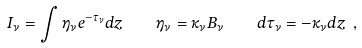Convert formula to latex. <formula><loc_0><loc_0><loc_500><loc_500>I _ { \nu } = \int \eta _ { \nu } e ^ { - \tau _ { \nu } } d z \quad \eta _ { \nu } = \kappa _ { \nu } B _ { \nu } \quad d \tau _ { \nu } = - \kappa _ { \nu } d z \ ,</formula> 